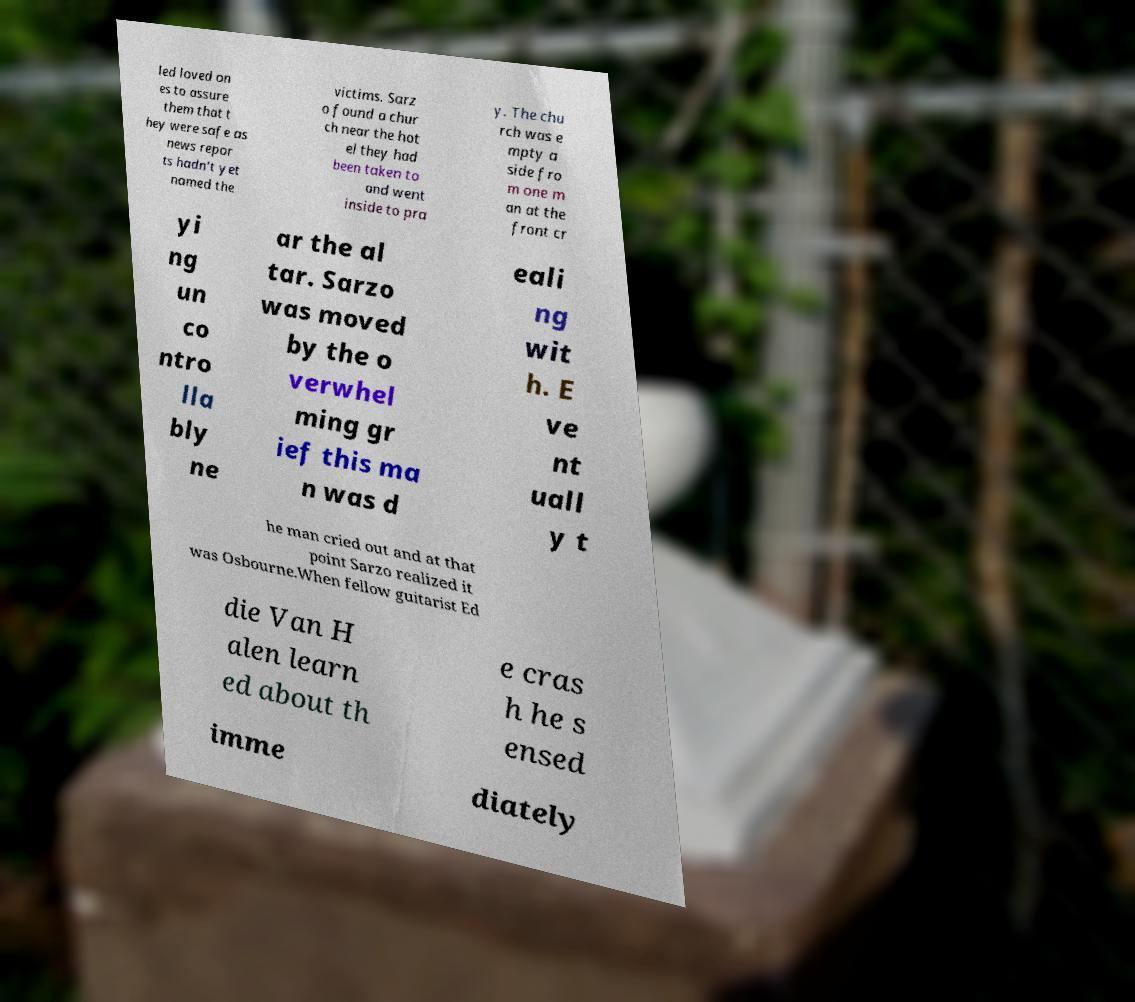Can you accurately transcribe the text from the provided image for me? led loved on es to assure them that t hey were safe as news repor ts hadn't yet named the victims. Sarz o found a chur ch near the hot el they had been taken to and went inside to pra y. The chu rch was e mpty a side fro m one m an at the front cr yi ng un co ntro lla bly ne ar the al tar. Sarzo was moved by the o verwhel ming gr ief this ma n was d eali ng wit h. E ve nt uall y t he man cried out and at that point Sarzo realized it was Osbourne.When fellow guitarist Ed die Van H alen learn ed about th e cras h he s ensed imme diately 